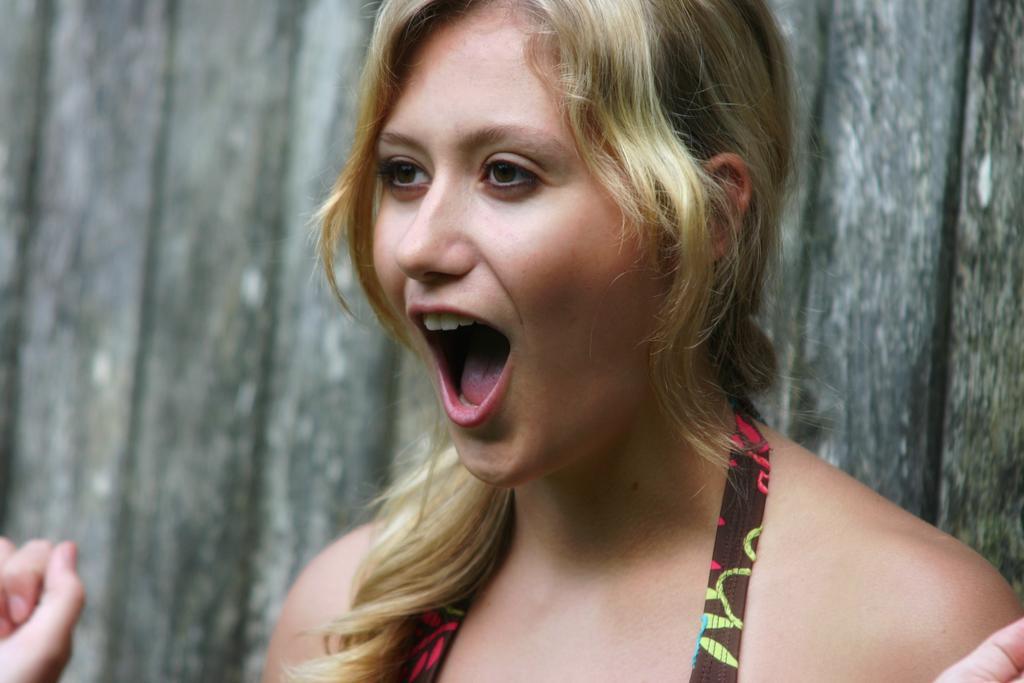Please provide a concise description of this image. In this image, we can see a woman standing and we can see a wooden wall. 